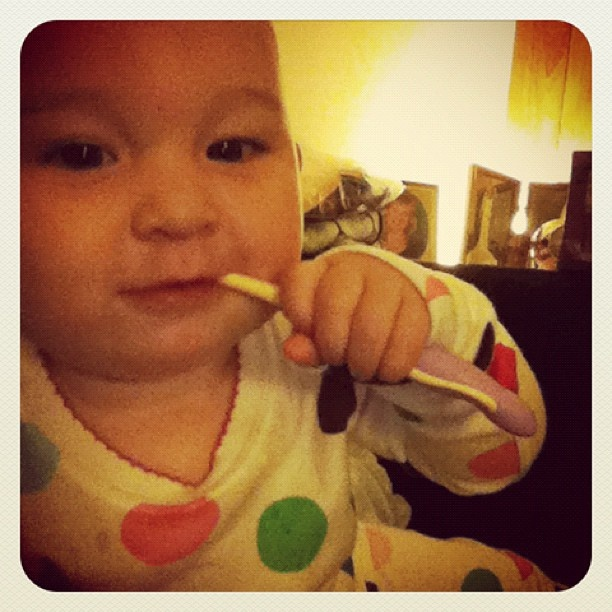Describe the objects in this image and their specific colors. I can see people in ivory, brown, maroon, and tan tones, bed in ivory, brown, maroon, and khaki tones, and toothbrush in ivory, salmon, brown, maroon, and tan tones in this image. 